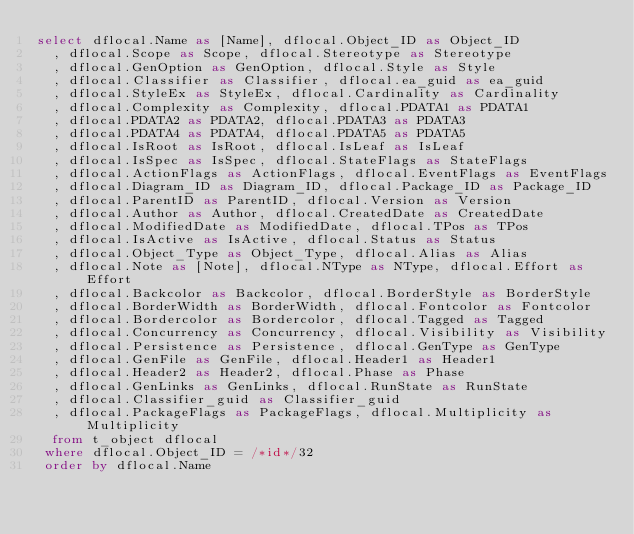<code> <loc_0><loc_0><loc_500><loc_500><_SQL_>select dflocal.Name as [Name], dflocal.Object_ID as Object_ID
  , dflocal.Scope as Scope, dflocal.Stereotype as Stereotype
  , dflocal.GenOption as GenOption, dflocal.Style as Style
  , dflocal.Classifier as Classifier, dflocal.ea_guid as ea_guid
  , dflocal.StyleEx as StyleEx, dflocal.Cardinality as Cardinality
  , dflocal.Complexity as Complexity, dflocal.PDATA1 as PDATA1
  , dflocal.PDATA2 as PDATA2, dflocal.PDATA3 as PDATA3
  , dflocal.PDATA4 as PDATA4, dflocal.PDATA5 as PDATA5
  , dflocal.IsRoot as IsRoot, dflocal.IsLeaf as IsLeaf
  , dflocal.IsSpec as IsSpec, dflocal.StateFlags as StateFlags
  , dflocal.ActionFlags as ActionFlags, dflocal.EventFlags as EventFlags
  , dflocal.Diagram_ID as Diagram_ID, dflocal.Package_ID as Package_ID
  , dflocal.ParentID as ParentID, dflocal.Version as Version
  , dflocal.Author as Author, dflocal.CreatedDate as CreatedDate
  , dflocal.ModifiedDate as ModifiedDate, dflocal.TPos as TPos
  , dflocal.IsActive as IsActive, dflocal.Status as Status
  , dflocal.Object_Type as Object_Type, dflocal.Alias as Alias
  , dflocal.Note as [Note], dflocal.NType as NType, dflocal.Effort as Effort
  , dflocal.Backcolor as Backcolor, dflocal.BorderStyle as BorderStyle
  , dflocal.BorderWidth as BorderWidth, dflocal.Fontcolor as Fontcolor
  , dflocal.Bordercolor as Bordercolor, dflocal.Tagged as Tagged
  , dflocal.Concurrency as Concurrency, dflocal.Visibility as Visibility
  , dflocal.Persistence as Persistence, dflocal.GenType as GenType
  , dflocal.GenFile as GenFile, dflocal.Header1 as Header1
  , dflocal.Header2 as Header2, dflocal.Phase as Phase
  , dflocal.GenLinks as GenLinks, dflocal.RunState as RunState
  , dflocal.Classifier_guid as Classifier_guid
  , dflocal.PackageFlags as PackageFlags, dflocal.Multiplicity as Multiplicity 
  from t_object dflocal 
 where dflocal.Object_ID = /*id*/32
 order by dflocal.Name</code> 